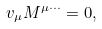<formula> <loc_0><loc_0><loc_500><loc_500>v _ { \mu } M ^ { \mu \cdots } = 0 ,</formula> 